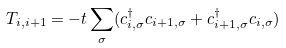Convert formula to latex. <formula><loc_0><loc_0><loc_500><loc_500>T _ { i , i + 1 } = - t \sum _ { \sigma } ( c _ { i , \sigma } ^ { \dagger } c _ { i + 1 , \sigma } + c _ { i + 1 , \sigma } ^ { \dagger } c _ { i , \sigma } )</formula> 